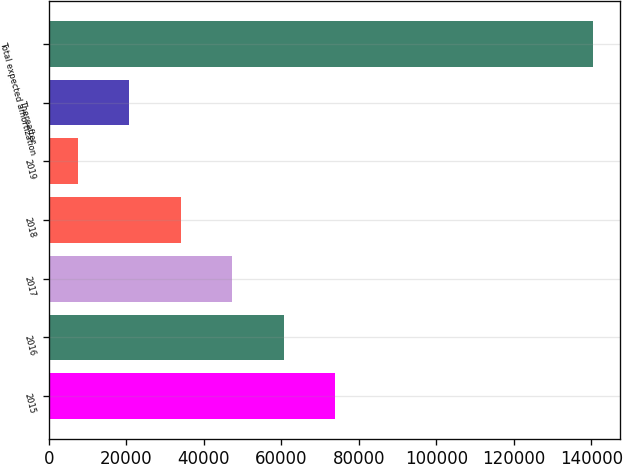<chart> <loc_0><loc_0><loc_500><loc_500><bar_chart><fcel>2015<fcel>2016<fcel>2017<fcel>2018<fcel>2019<fcel>Thereafter<fcel>Total expected amortization<nl><fcel>73969.5<fcel>60661.2<fcel>47352.9<fcel>34044.6<fcel>7428<fcel>20736.3<fcel>140511<nl></chart> 